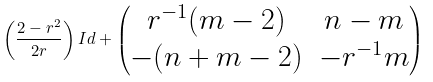Convert formula to latex. <formula><loc_0><loc_0><loc_500><loc_500>\left ( \frac { 2 - r ^ { 2 } } { 2 r } \right ) I d + \begin{pmatrix} r ^ { - 1 } ( m - 2 ) & n - m \\ - ( n + m - 2 ) & - r ^ { - 1 } m \end{pmatrix}</formula> 